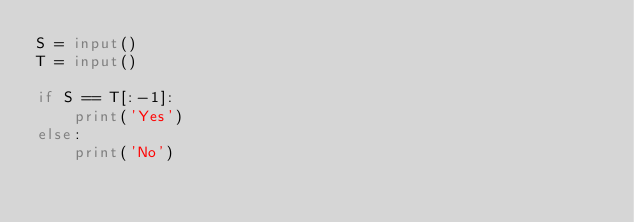Convert code to text. <code><loc_0><loc_0><loc_500><loc_500><_Python_>S = input()
T = input()

if S == T[:-1]:
    print('Yes')
else:
    print('No')</code> 